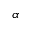<formula> <loc_0><loc_0><loc_500><loc_500>\alpha</formula> 